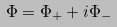<formula> <loc_0><loc_0><loc_500><loc_500>\Phi = \Phi _ { + } + i \Phi _ { - }</formula> 